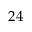Convert formula to latex. <formula><loc_0><loc_0><loc_500><loc_500>2 4</formula> 